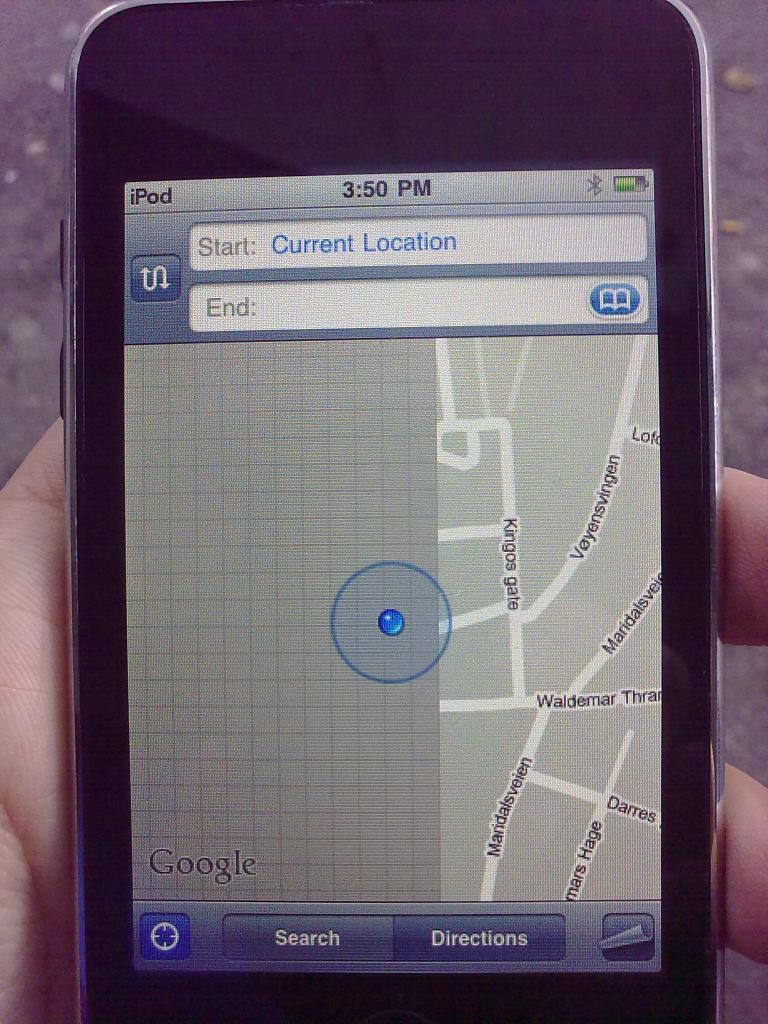What time does it read?
Keep it short and to the point. 3:50pm. Where does this person begin?
Give a very brief answer. Current location. 